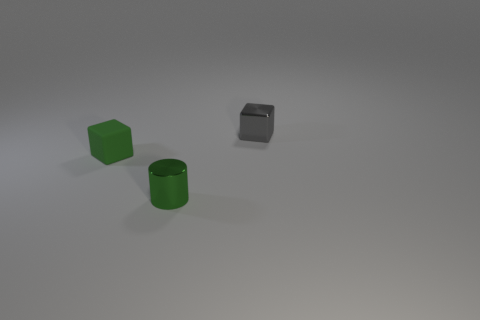Is there any other thing that is the same shape as the green metallic object?
Your answer should be compact. No. Are there any tiny green shiny cylinders that are left of the green matte object behind the tiny green metallic cylinder?
Give a very brief answer. No. What material is the gray thing?
Give a very brief answer. Metal. There is a tiny gray metallic thing; are there any cubes left of it?
Offer a very short reply. Yes. Is the number of small green cylinders in front of the tiny green cylinder the same as the number of tiny gray metal blocks that are on the left side of the small gray block?
Offer a very short reply. Yes. How many yellow rubber cubes are there?
Keep it short and to the point. 0. Is the number of tiny shiny blocks that are behind the green matte block greater than the number of large brown rubber cubes?
Ensure brevity in your answer.  Yes. There is a tiny green cylinder on the left side of the gray metal block; what is its material?
Provide a short and direct response. Metal. There is another small thing that is the same shape as the tiny gray thing; what is its color?
Offer a very short reply. Green. How many small objects have the same color as the tiny shiny cylinder?
Make the answer very short. 1. 